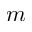<formula> <loc_0><loc_0><loc_500><loc_500>m</formula> 